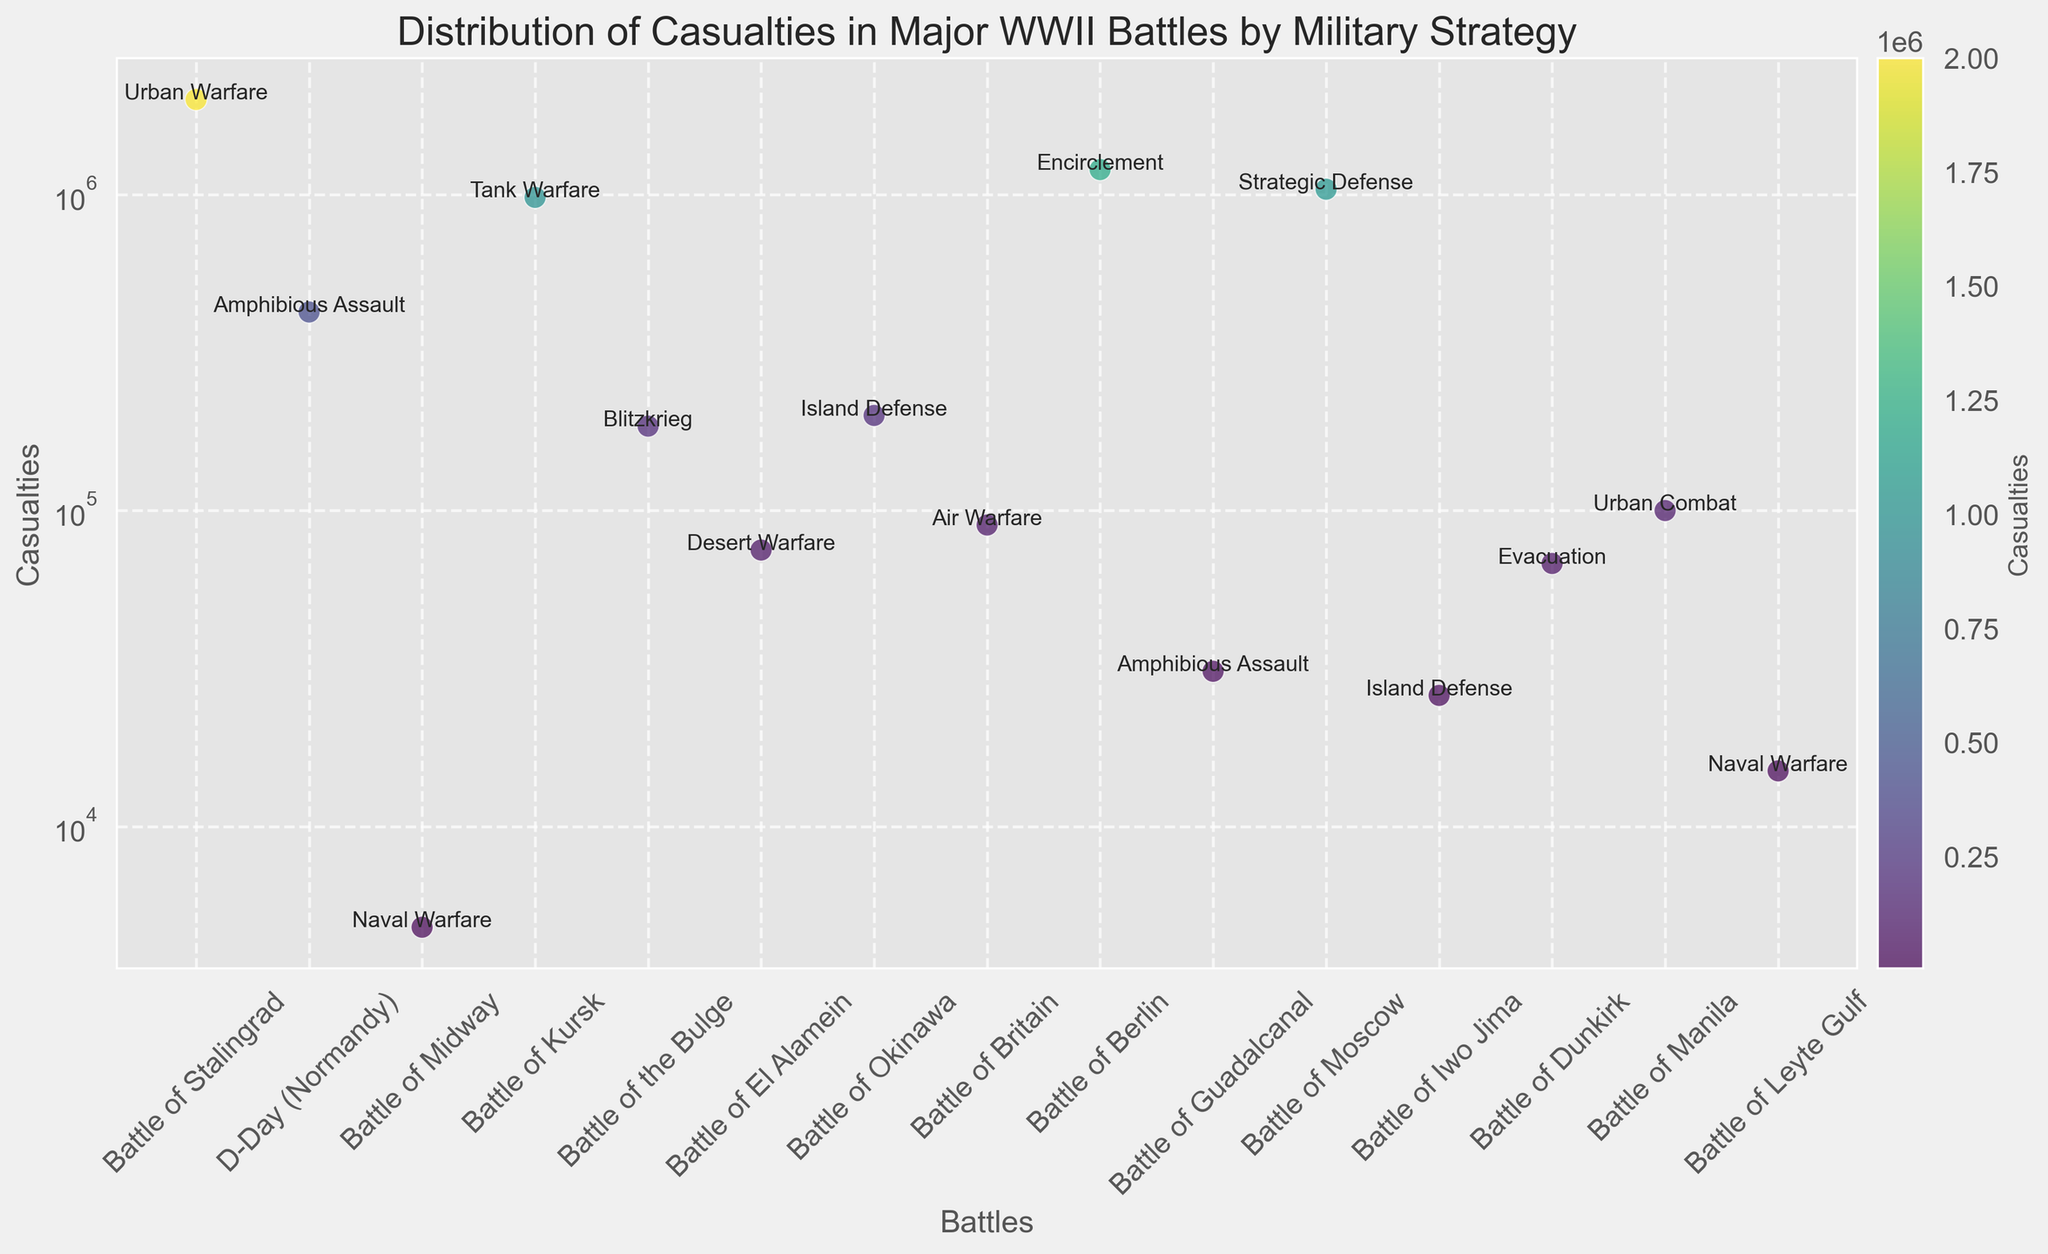What's the battle with the most casualties? Look at the scatter plot and note which battle has the highest casualty count. Here, it is clear from the y-axis that the Battle of Stalingrad has the highest number of casualties.
Answer: Battle of Stalingrad Which military strategy is used in the battle with the second highest casualties? Identify the second highest point on the y-axis, which corresponds to the Battle of Berlin. From the annotations, see the associated military strategy.
Answer: Encirclement What's the total number of casualties for battles employing Naval Warfare? Locate battles using Naval Warfare (Battle of Midway and Battle of Leyte Gulf). Sum their casualties: 4800 (Midway) + 15000 (Leyte Gulf) = 19800.
Answer: 19800 Which battle has fewer casualties: Battle of El Alamein or Battle of the Bulge? Compare the y-axis values for both battles. The Battle of El Alamein has fewer casualties (75000) compared to the Battle of the Bulge (185000).
Answer: Battle of El Alamein What is the average number of casualties for battles using the Amphibious Assault strategy? Identify the battles with Amphibious Assault (D-Day, Battle of Guadalcanal). Sum their casualties and divide by the number of battles: (425000 + 31000) / 2 = 228000.
Answer: 228000 Which military strategy corresponds to the color representing the highest casualty count? The highest casualty count is marked in a distinct color (usually the darkest on a viridis colormap). Checking the annotations at the highest point (Battle of Stalingrad), the strategy is Urban Warfare.
Answer: Urban Warfare Is the Battle of Okinawa's casualty count higher or lower than that of the Battle of Kursk? Compare their positions on the y-axis. The Battle of Okinawa has 200000 casualties, whereas the Battle of Kursk has 980000.
Answer: Lower What is the median casualty count for the listed battles? Arrange the casualties in ascending order and find the middle value. The median is more easily extracted from the overall distribution. Here, the sorted list of casualties: 4800, 15000, 26000, 31000, 68000, 75000, 90000, 100000, 185000, 200000, 425000, 980000, 1040000, 1200000, 2000000. The median is 100000 (Battle of Manila).
Answer: 100000 Which battle annotation appears at the highest position in the plot? The highest position in the plot corresponds to the highest y-axis value. The annotation is "Urban Warfare," associated with the Battle of Stalingrad.
Answer: Urban Warfare Which two battles have a casualty count ending in '000', and what is their combined total? Identify battles ending in '000': Battle of the Bulge (185000) and Battle of El Alamein (75000). Their combined total is 185000 + 75000 = 260000.
Answer: 260000 